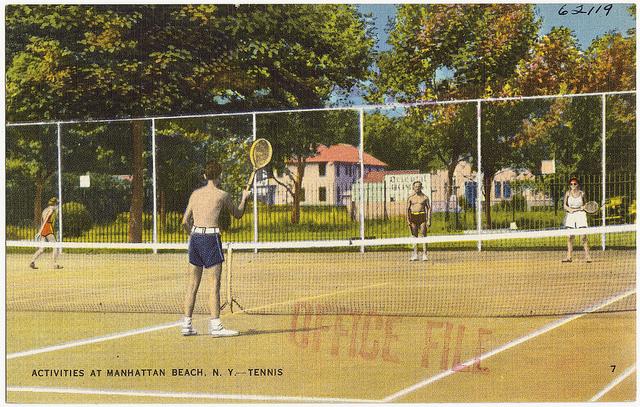Is this a photo taken yesterday?
Write a very short answer. No. Does this look like an illustration in a book?
Quick response, please. Yes. Why don't the two men have shirts on?
Write a very short answer. It's hot. 